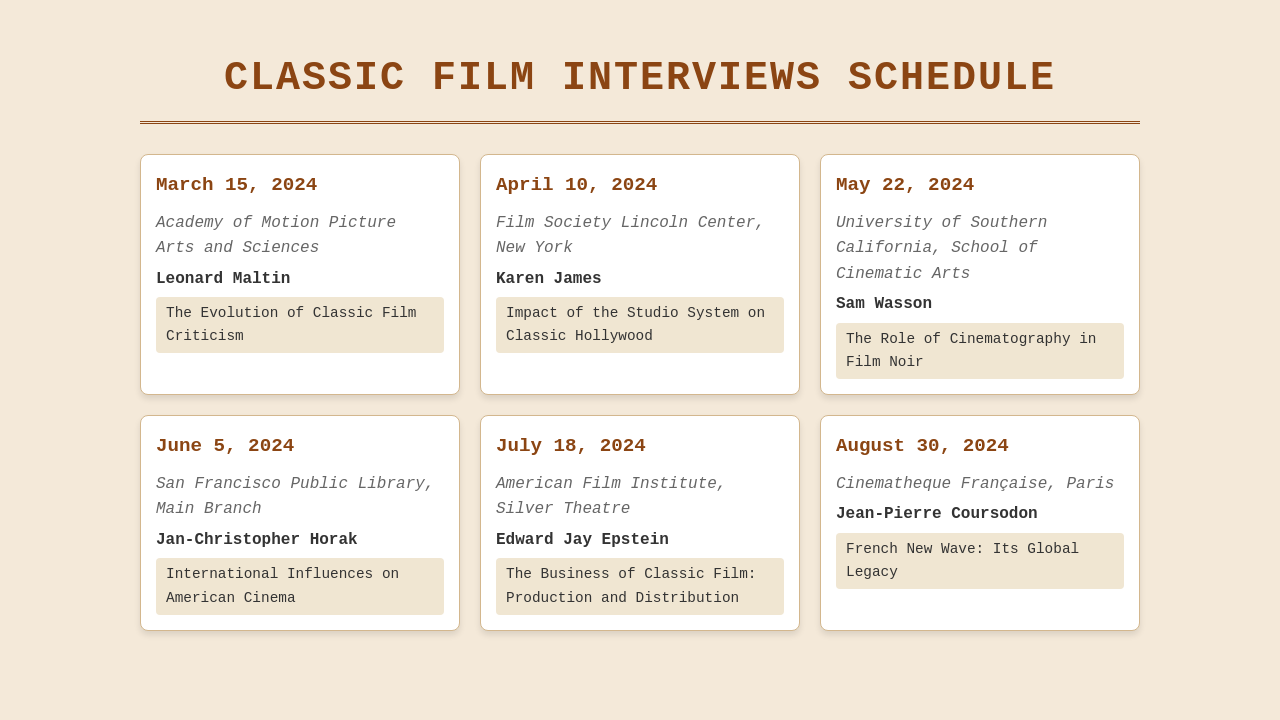What is the date of the first interview? The date of the first interview is provided in the schedule, which is March 15, 2024.
Answer: March 15, 2024 Who is the expert for the interview on May 22, 2024? The expert for the interview on May 22, 2024, is listed in the document as Sam Wasson.
Answer: Sam Wasson Where will the interview with Edward Jay Epstein take place? The venue for Edward Jay Epstein's interview is specified in the document, which is American Film Institute, Silver Theatre.
Answer: American Film Institute, Silver Theatre What topic will be discussed on June 5, 2024? The topic for the interview on June 5, 2024, is clearly stated in the document as International Influences on American Cinema.
Answer: International Influences on American Cinema How many interviews are scheduled before August 30, 2024? The number of interviews scheduled before August 30, 2024, can be counted from the document, totaling 5 interviews.
Answer: 5 Which venue is hosting the interview on April 10, 2024? The venue for the interview on April 10, 2024, is mentioned in the document as Film Society Lincoln Center, New York.
Answer: Film Society Lincoln Center, New York What is the primary focus of the interview with Karen James? The focus of the interview with Karen James is detailed in the document as the Impact of the Studio System on Classic Hollywood.
Answer: Impact of the Studio System on Classic Hollywood What type of document is this? The nature of the document can be identified as a schedule for interviews related to classic films.
Answer: Schedule of interviews 